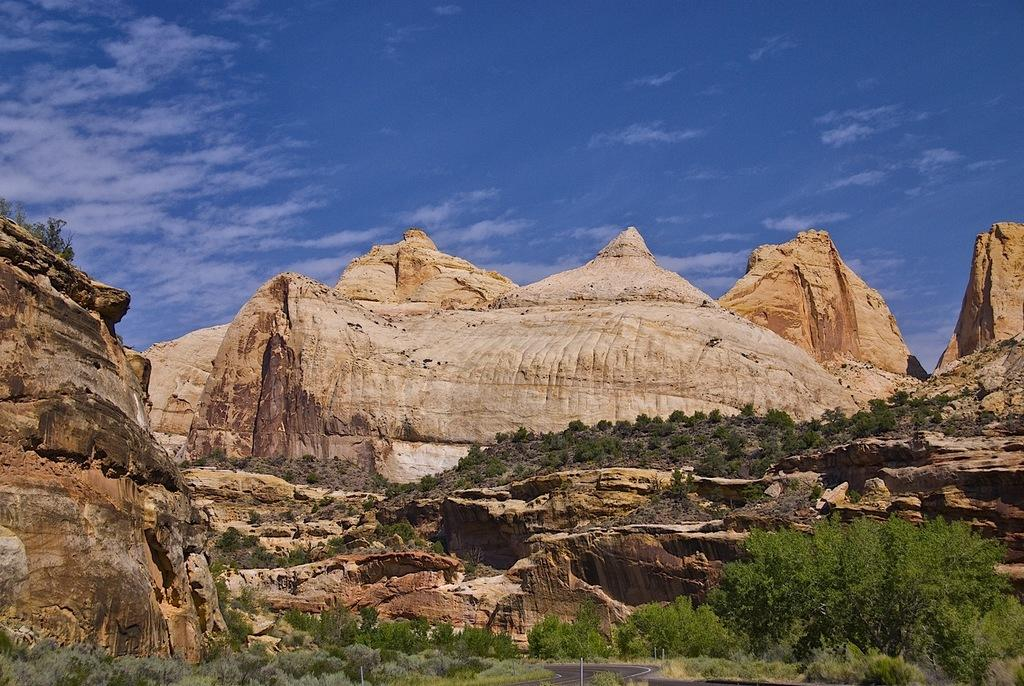What geographical feature is located in the center of the image? There are hills in the center of the image. What type of vegetation can be seen at the bottom of the image? There are trees at the bottom of the image. What round object is present at the bottom of the image? There is a round object at the bottom of the image. What is visible at the top of the image? The sky is visible at the top of the image. What can be observed in the sky? There are clouds in the sky. What type of calendar is hanging on the tree in the image? There is no calendar present in the image; it features hills, trees, a round object, and clouds in the sky. What flavor of pie is being served on the hills in the image? There is no pie present in the image; it features hills, trees, a round object, and clouds in the sky. 